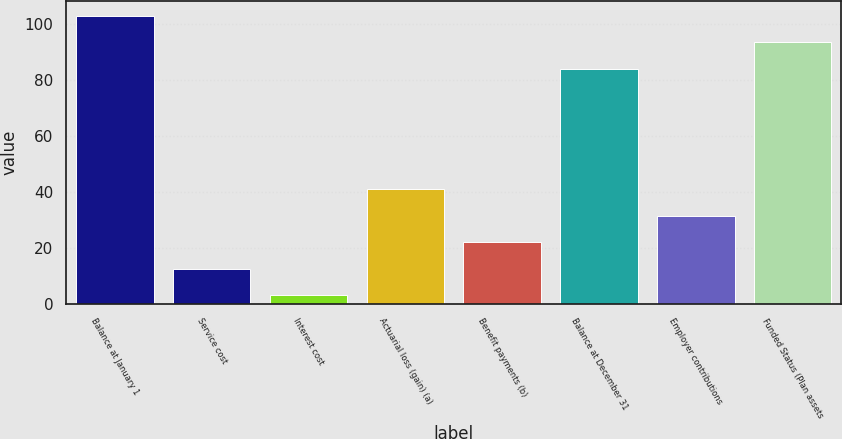Convert chart to OTSL. <chart><loc_0><loc_0><loc_500><loc_500><bar_chart><fcel>Balance at January 1<fcel>Service cost<fcel>Interest cost<fcel>Actuarial loss (gain) (a)<fcel>Benefit payments (b)<fcel>Balance at December 31<fcel>Employer contributions<fcel>Funded Status (Plan assets<nl><fcel>103<fcel>12.5<fcel>3<fcel>41<fcel>22<fcel>84<fcel>31.5<fcel>93.5<nl></chart> 